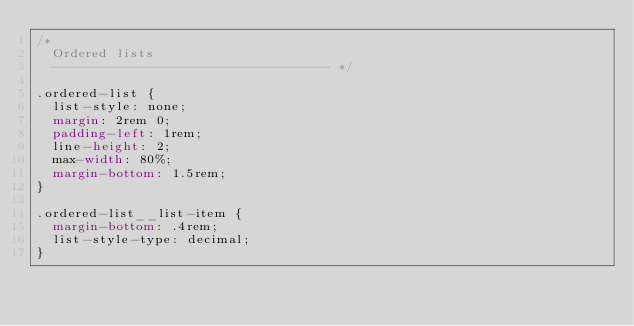Convert code to text. <code><loc_0><loc_0><loc_500><loc_500><_CSS_>/*
  Ordered lists
  ----------------------------------- */

.ordered-list {
  list-style: none;
  margin: 2rem 0;
  padding-left: 1rem;
  line-height: 2;
  max-width: 80%;
  margin-bottom: 1.5rem;
}

.ordered-list__list-item {
  margin-bottom: .4rem;
  list-style-type: decimal;
}
</code> 